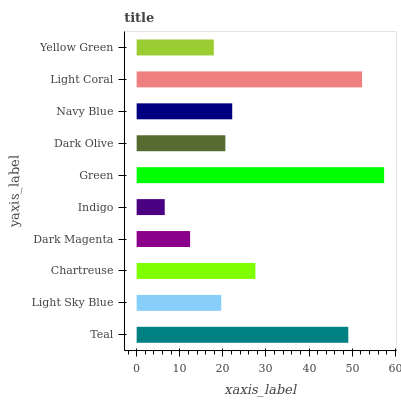Is Indigo the minimum?
Answer yes or no. Yes. Is Green the maximum?
Answer yes or no. Yes. Is Light Sky Blue the minimum?
Answer yes or no. No. Is Light Sky Blue the maximum?
Answer yes or no. No. Is Teal greater than Light Sky Blue?
Answer yes or no. Yes. Is Light Sky Blue less than Teal?
Answer yes or no. Yes. Is Light Sky Blue greater than Teal?
Answer yes or no. No. Is Teal less than Light Sky Blue?
Answer yes or no. No. Is Navy Blue the high median?
Answer yes or no. Yes. Is Dark Olive the low median?
Answer yes or no. Yes. Is Green the high median?
Answer yes or no. No. Is Teal the low median?
Answer yes or no. No. 